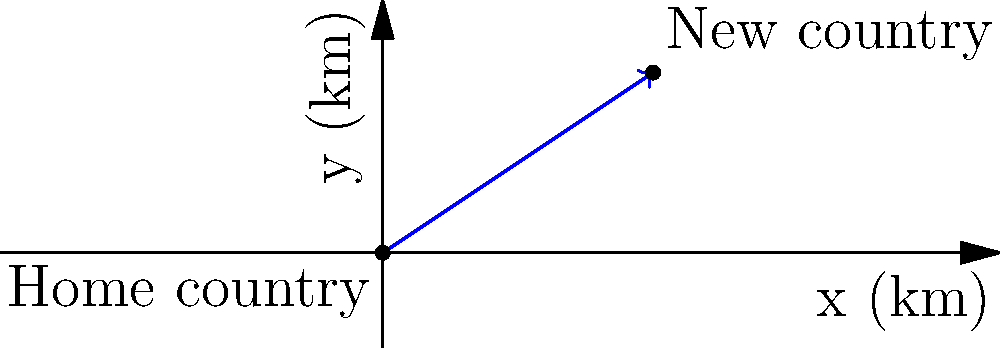A vector represents the migration route from a newly independent country to a new host country. If the x-component of the vector is 3000 km east and the y-component is 2000 km north, what are the magnitude and direction (in degrees from east) of this migration vector? To solve this problem, we need to follow these steps:

1. Identify the components of the vector:
   x-component = 3000 km east
   y-component = 2000 km north

2. Calculate the magnitude using the Pythagorean theorem:
   $\text{magnitude} = \sqrt{x^2 + y^2}$
   $\text{magnitude} = \sqrt{3000^2 + 2000^2}$
   $\text{magnitude} = \sqrt{9,000,000 + 4,000,000}$
   $\text{magnitude} = \sqrt{13,000,000}$
   $\text{magnitude} \approx 3605.55$ km

3. Calculate the direction using the arctangent function:
   $\text{direction} = \tan^{-1}(\frac{y}{x})$
   $\text{direction} = \tan^{-1}(\frac{2000}{3000})$
   $\text{direction} = \tan^{-1}(0.6667)$
   $\text{direction} \approx 33.69°$

Therefore, the migration vector has a magnitude of approximately 3605.55 km and a direction of 33.69° from east.
Answer: Magnitude: 3605.55 km, Direction: 33.69° 